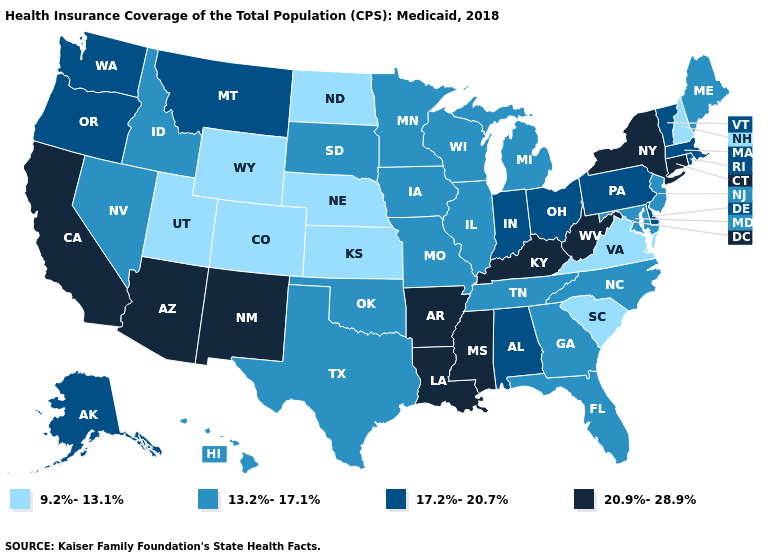What is the value of Washington?
Be succinct. 17.2%-20.7%. What is the lowest value in states that border Florida?
Give a very brief answer. 13.2%-17.1%. What is the value of Minnesota?
Be succinct. 13.2%-17.1%. Which states have the lowest value in the West?
Keep it brief. Colorado, Utah, Wyoming. What is the value of Montana?
Quick response, please. 17.2%-20.7%. Among the states that border Wisconsin , which have the highest value?
Answer briefly. Illinois, Iowa, Michigan, Minnesota. What is the lowest value in the West?
Concise answer only. 9.2%-13.1%. Name the states that have a value in the range 13.2%-17.1%?
Quick response, please. Florida, Georgia, Hawaii, Idaho, Illinois, Iowa, Maine, Maryland, Michigan, Minnesota, Missouri, Nevada, New Jersey, North Carolina, Oklahoma, South Dakota, Tennessee, Texas, Wisconsin. What is the value of West Virginia?
Give a very brief answer. 20.9%-28.9%. What is the value of Nevada?
Concise answer only. 13.2%-17.1%. Does the first symbol in the legend represent the smallest category?
Write a very short answer. Yes. What is the value of North Dakota?
Keep it brief. 9.2%-13.1%. Does Nebraska have the lowest value in the USA?
Answer briefly. Yes. How many symbols are there in the legend?
Answer briefly. 4. 